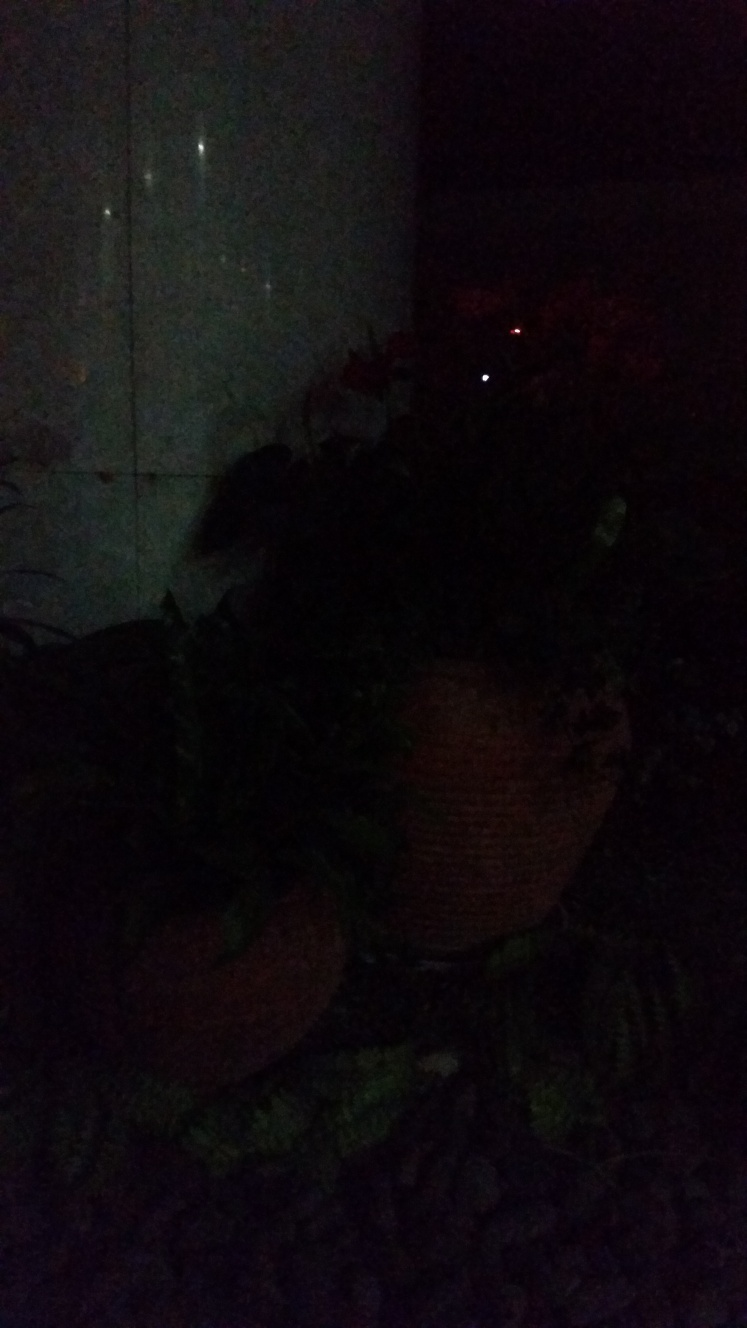What is the quality of this image?
A. excellent
B. average
C. very poor
Answer with the option's letter from the given choices directly. The quality of the image is quite low; hence the most accurate answer is option C, very poor. The image is very dark, making it hard to discern details, and it lacks proper lighting and clarity which are key aspects of image quality. 